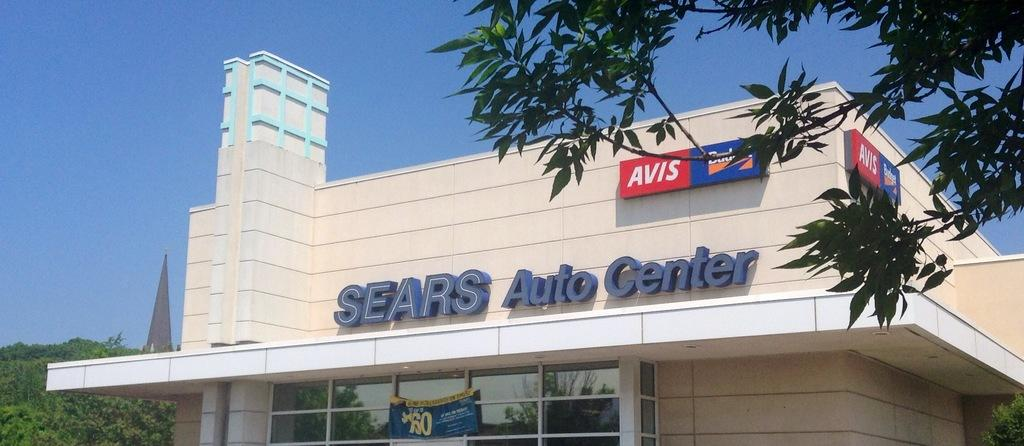<image>
Create a compact narrative representing the image presented. AVIS is advertised above the Sears sign on a building. 